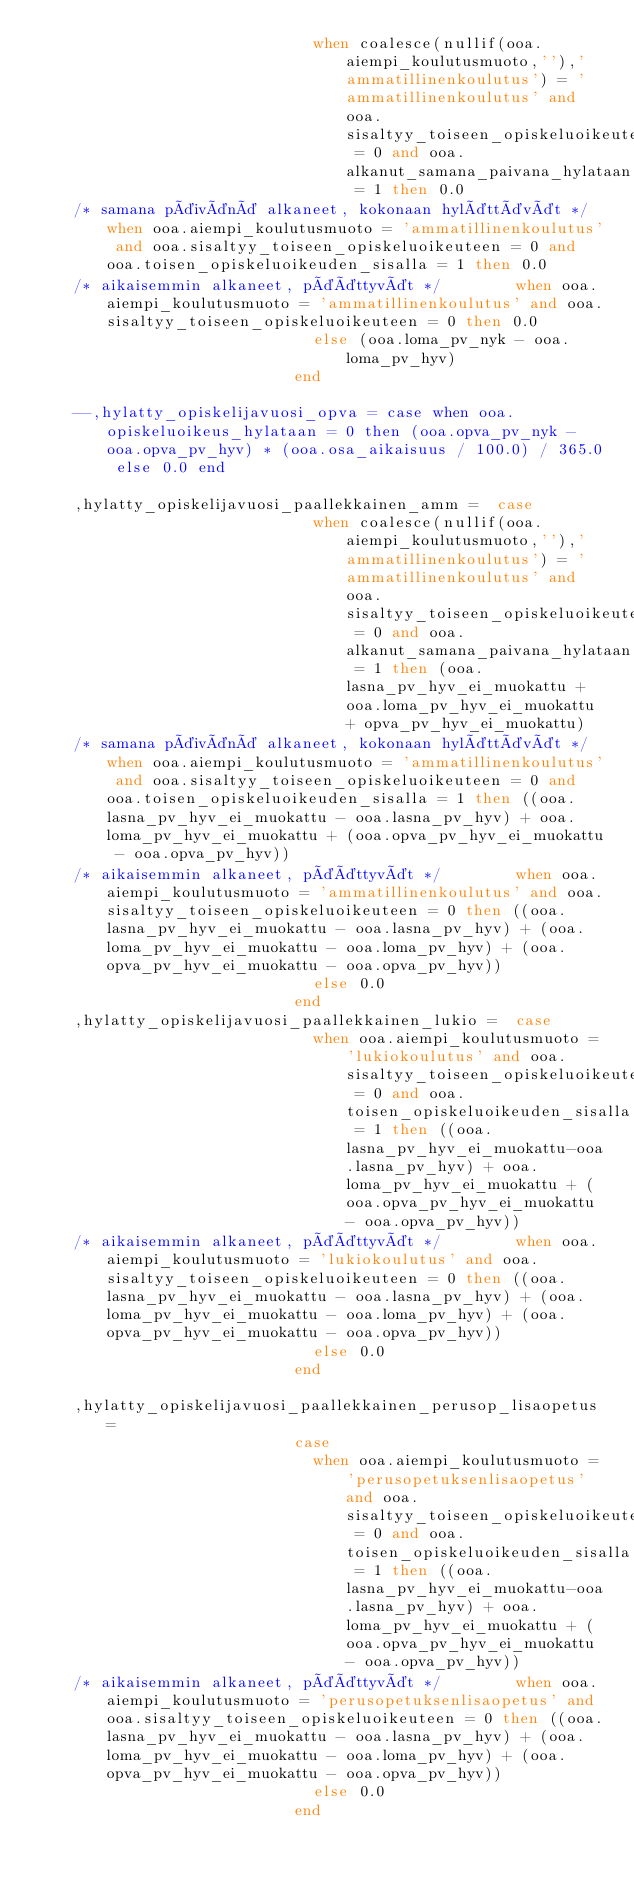Convert code to text. <code><loc_0><loc_0><loc_500><loc_500><_SQL_>															when coalesce(nullif(ooa.aiempi_koulutusmuoto,''),'ammatillinenkoulutus') = 'ammatillinenkoulutus' and ooa.sisaltyy_toiseen_opiskeluoikeuteen = 0 and ooa.alkanut_samana_paivana_hylataan = 1 then 0.0
		/* samana päivänä alkaneet, kokonaan hylättävät */	when ooa.aiempi_koulutusmuoto = 'ammatillinenkoulutus' and ooa.sisaltyy_toiseen_opiskeluoikeuteen = 0 and ooa.toisen_opiskeluoikeuden_sisalla = 1 then 0.0
		/* aikaisemmin alkaneet, päättyvät */				when ooa.aiempi_koulutusmuoto = 'ammatillinenkoulutus' and ooa.sisaltyy_toiseen_opiskeluoikeuteen = 0 then 0.0
															else (ooa.loma_pv_nyk - ooa.loma_pv_hyv) 
														end 

		--,hylatty_opiskelijavuosi_opva = case when ooa.opiskeluoikeus_hylataan = 0 then (ooa.opva_pv_nyk - ooa.opva_pv_hyv) * (ooa.osa_aikaisuus / 100.0) / 365.0 else 0.0 end

		,hylatty_opiskelijavuosi_paallekkainen_amm =	case
															when coalesce(nullif(ooa.aiempi_koulutusmuoto,''),'ammatillinenkoulutus') = 'ammatillinenkoulutus' and ooa.sisaltyy_toiseen_opiskeluoikeuteen = 0 and ooa.alkanut_samana_paivana_hylataan = 1 then (ooa.lasna_pv_hyv_ei_muokattu + ooa.loma_pv_hyv_ei_muokattu + opva_pv_hyv_ei_muokattu) 
		/* samana päivänä alkaneet, kokonaan hylättävät */	when ooa.aiempi_koulutusmuoto = 'ammatillinenkoulutus' and ooa.sisaltyy_toiseen_opiskeluoikeuteen = 0 and ooa.toisen_opiskeluoikeuden_sisalla = 1 then ((ooa.lasna_pv_hyv_ei_muokattu - ooa.lasna_pv_hyv) + ooa.loma_pv_hyv_ei_muokattu + (ooa.opva_pv_hyv_ei_muokattu - ooa.opva_pv_hyv))  
		/* aikaisemmin alkaneet, päättyvät */				when ooa.aiempi_koulutusmuoto = 'ammatillinenkoulutus' and ooa.sisaltyy_toiseen_opiskeluoikeuteen = 0 then ((ooa.lasna_pv_hyv_ei_muokattu - ooa.lasna_pv_hyv) + (ooa.loma_pv_hyv_ei_muokattu - ooa.loma_pv_hyv) + (ooa.opva_pv_hyv_ei_muokattu - ooa.opva_pv_hyv)) 
															else 0.0 
														end
		,hylatty_opiskelijavuosi_paallekkainen_lukio =	case
															when ooa.aiempi_koulutusmuoto = 'lukiokoulutus' and ooa.sisaltyy_toiseen_opiskeluoikeuteen = 0 and ooa.toisen_opiskeluoikeuden_sisalla = 1 then ((ooa.lasna_pv_hyv_ei_muokattu-ooa.lasna_pv_hyv) + ooa.loma_pv_hyv_ei_muokattu + (ooa.opva_pv_hyv_ei_muokattu - ooa.opva_pv_hyv)) 
		/* aikaisemmin alkaneet, päättyvät */				when ooa.aiempi_koulutusmuoto = 'lukiokoulutus' and ooa.sisaltyy_toiseen_opiskeluoikeuteen = 0 then ((ooa.lasna_pv_hyv_ei_muokattu - ooa.lasna_pv_hyv) + (ooa.loma_pv_hyv_ei_muokattu - ooa.loma_pv_hyv) + (ooa.opva_pv_hyv_ei_muokattu - ooa.opva_pv_hyv)) 
															else 0.0 
														end

		,hylatty_opiskelijavuosi_paallekkainen_perusop_lisaopetus =	
														case
															when ooa.aiempi_koulutusmuoto = 'perusopetuksenlisaopetus' and ooa.sisaltyy_toiseen_opiskeluoikeuteen = 0 and ooa.toisen_opiskeluoikeuden_sisalla = 1 then ((ooa.lasna_pv_hyv_ei_muokattu-ooa.lasna_pv_hyv) + ooa.loma_pv_hyv_ei_muokattu + (ooa.opva_pv_hyv_ei_muokattu - ooa.opva_pv_hyv)) 
		/* aikaisemmin alkaneet, päättyvät */				when ooa.aiempi_koulutusmuoto = 'perusopetuksenlisaopetus' and ooa.sisaltyy_toiseen_opiskeluoikeuteen = 0 then ((ooa.lasna_pv_hyv_ei_muokattu - ooa.lasna_pv_hyv) + (ooa.loma_pv_hyv_ei_muokattu - ooa.loma_pv_hyv) + (ooa.opva_pv_hyv_ei_muokattu - ooa.opva_pv_hyv)) 
															else 0.0 
														end
</code> 